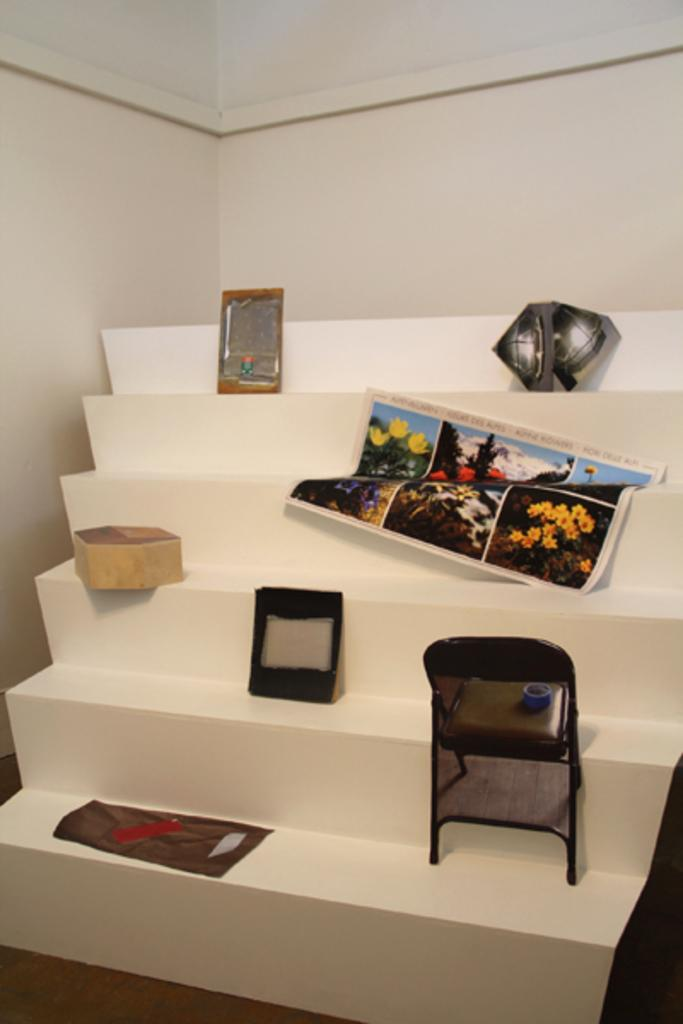What type of objects or devices can be seen in the image? There are electronic devices or objects in the image. However, without more specific information about the electronic devices or objects, we cannot provide more detailed facts. Can you tell me how many kittens are playing in harmony with the electronic devices in the image? There are no kittens present in the image, and the electronic devices are not interacting with any living beings. Is there a turkey visible in the image? There is no turkey present in the image. 